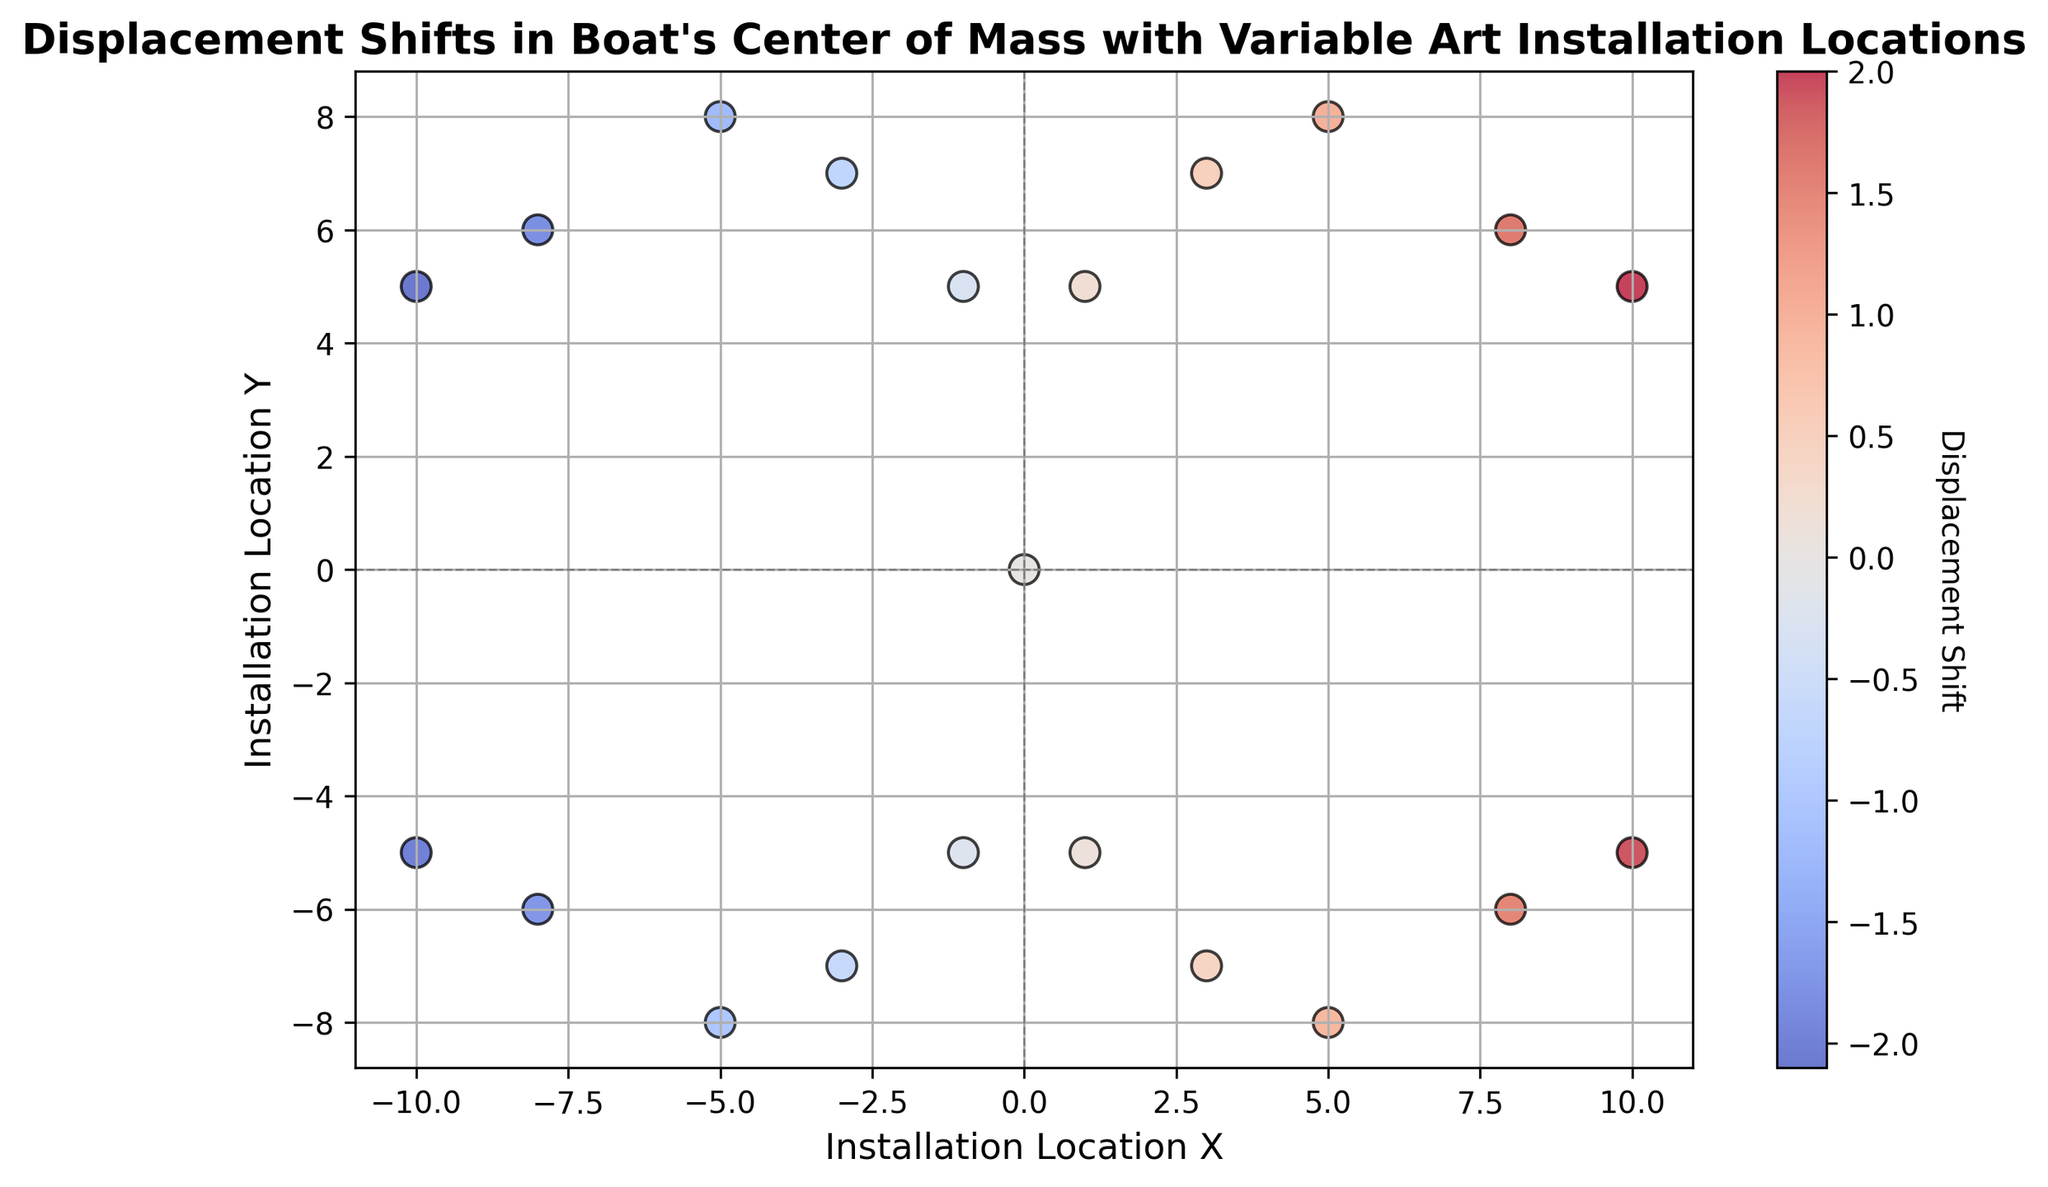What color represents a displacement shift close to zero? The colorbar in the figure shows that displacement shifts close to zero are represented by a neutral color between the extremes. In the case of this color map, it is likely to be a shade of white or light gray.
Answer: Neutral (white/light gray) Which installation locations result in the highest positive displacement shift? By examining the scatter plot, the highest positive displacement shifts are identified by the most intense red color and are located at (10, 5) and (10, -5).
Answer: (10, 5) and (10, -5) Is there symmetry in the displacement shifts with respect to the x-axis? The plot demonstrates symmetry in displacement shifts if points mirrored across the x-axis (positive and negative y-values with same x-value) have similar colors. Each point's counterpart across the x-axis has a similar displacement shift.
Answer: Yes How does the displacement shift change as the Installation Location X increases from -10 to 10 along the Y=5 line? By tracing the line Y=5 in the scatter plot, it’s clear that displacement shifts (color) steadily increase from -2.1 at X=-10 to 2.0 at X=10.
Answer: It increases Can you determine the displacement shift at the origin (0, 0)? According to the plot, the point at (0, 0) is where the displacement shift is zero, indicated by the neutral color.
Answer: 0 What is the average displacement shift for installation locations where Y=7? Identify the points (3, 7) and (-3, 7) on the plot with displacement shifts of 0.5 and -0.7 respectively. Calculate the average: (0.5 + (-0.7))/2 = -0.1.
Answer: -0.1 Which point has a higher displacement shift: (5, -8) or (-5, 8)? By comparing the points (5, -8) and (-5, 8) on the scatter plot, (5, -8) has a displacement shift of 0.9 whereas (-5, 8) has a displacement shift of -1.2.
Answer: (5, -8) Are there any installation locations where the displacement shift is exactly zero other than the origin? In the scatter plot, the point (0, 0) is the only location with a neutral color indicating a zero displacement shift.
Answer: No How many installation locations have positive displacement shifts? Count all points with a red hue indicating positive displacement shifts. The red points are at (1, 5), (3, 7), (5, 8), (8, 6), (10, 5), (1, -5), (3, -7), (5, -8), (8, -6), and (10, -5).
Answer: 10 What is the relationship between the displacement shift and the y-coordinate for x=5? Look at points with x=5: (5, 8) has 1.0 and (5, -8) has 0.9. As the y-coordinate changes from positive to negative, displacement shift slightly decreases.
Answer: Slightly decreases 